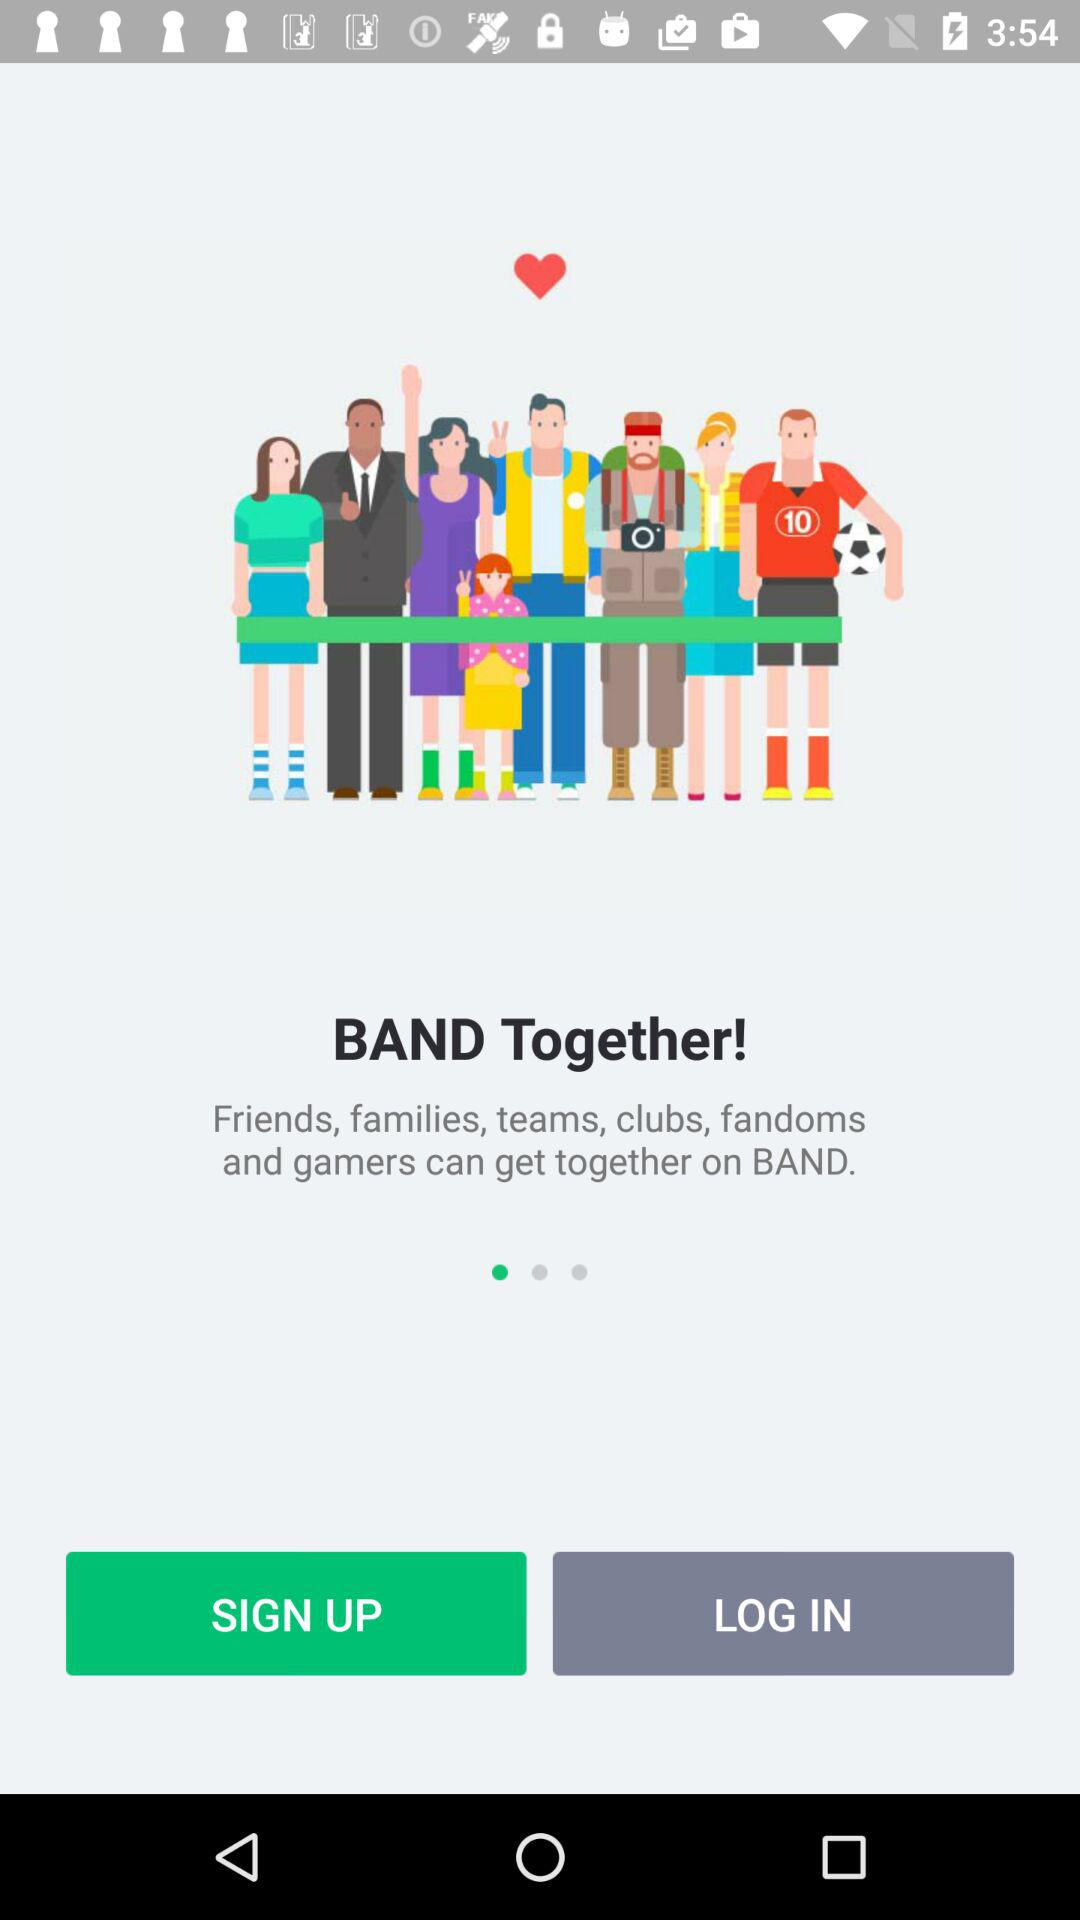Who can get together on "BAND"? The ones that can get together on "BAND" are friends, families, teams, clubs, fandoms and gamers. 